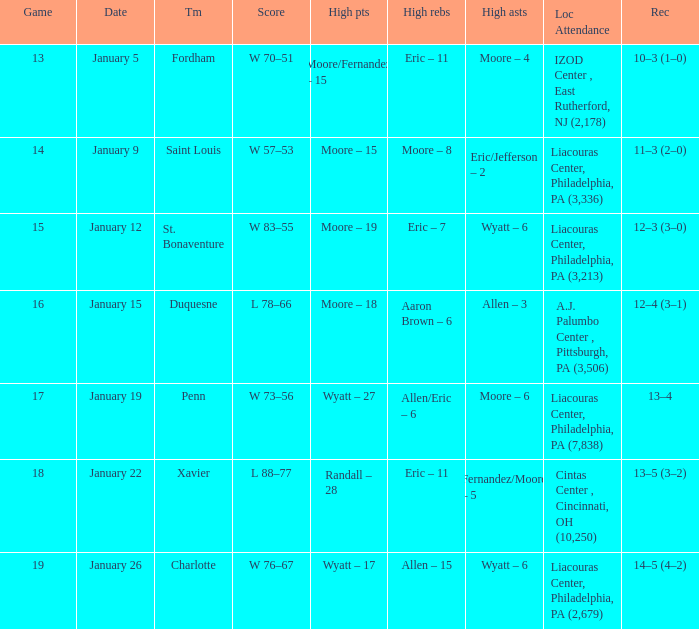Who had the most assists and how many did they have on January 5? Moore – 4. Write the full table. {'header': ['Game', 'Date', 'Tm', 'Score', 'High pts', 'High rebs', 'High asts', 'Loc Attendance', 'Rec'], 'rows': [['13', 'January 5', 'Fordham', 'W 70–51', 'Moore/Fernandez – 15', 'Eric – 11', 'Moore – 4', 'IZOD Center , East Rutherford, NJ (2,178)', '10–3 (1–0)'], ['14', 'January 9', 'Saint Louis', 'W 57–53', 'Moore – 15', 'Moore – 8', 'Eric/Jefferson – 2', 'Liacouras Center, Philadelphia, PA (3,336)', '11–3 (2–0)'], ['15', 'January 12', 'St. Bonaventure', 'W 83–55', 'Moore – 19', 'Eric – 7', 'Wyatt – 6', 'Liacouras Center, Philadelphia, PA (3,213)', '12–3 (3–0)'], ['16', 'January 15', 'Duquesne', 'L 78–66', 'Moore – 18', 'Aaron Brown – 6', 'Allen – 3', 'A.J. Palumbo Center , Pittsburgh, PA (3,506)', '12–4 (3–1)'], ['17', 'January 19', 'Penn', 'W 73–56', 'Wyatt – 27', 'Allen/Eric – 6', 'Moore – 6', 'Liacouras Center, Philadelphia, PA (7,838)', '13–4'], ['18', 'January 22', 'Xavier', 'L 88–77', 'Randall – 28', 'Eric – 11', 'Fernandez/Moore – 5', 'Cintas Center , Cincinnati, OH (10,250)', '13–5 (3–2)'], ['19', 'January 26', 'Charlotte', 'W 76–67', 'Wyatt – 17', 'Allen – 15', 'Wyatt – 6', 'Liacouras Center, Philadelphia, PA (2,679)', '14–5 (4–2)']]} 